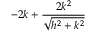Convert formula to latex. <formula><loc_0><loc_0><loc_500><loc_500>- 2 k + \frac { 2 k ^ { 2 } } { \sqrt { h ^ { 2 } + k ^ { 2 } } }</formula> 